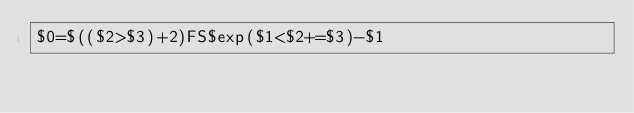<code> <loc_0><loc_0><loc_500><loc_500><_Awk_>$0=$(($2>$3)+2)FS$exp($1<$2+=$3)-$1</code> 